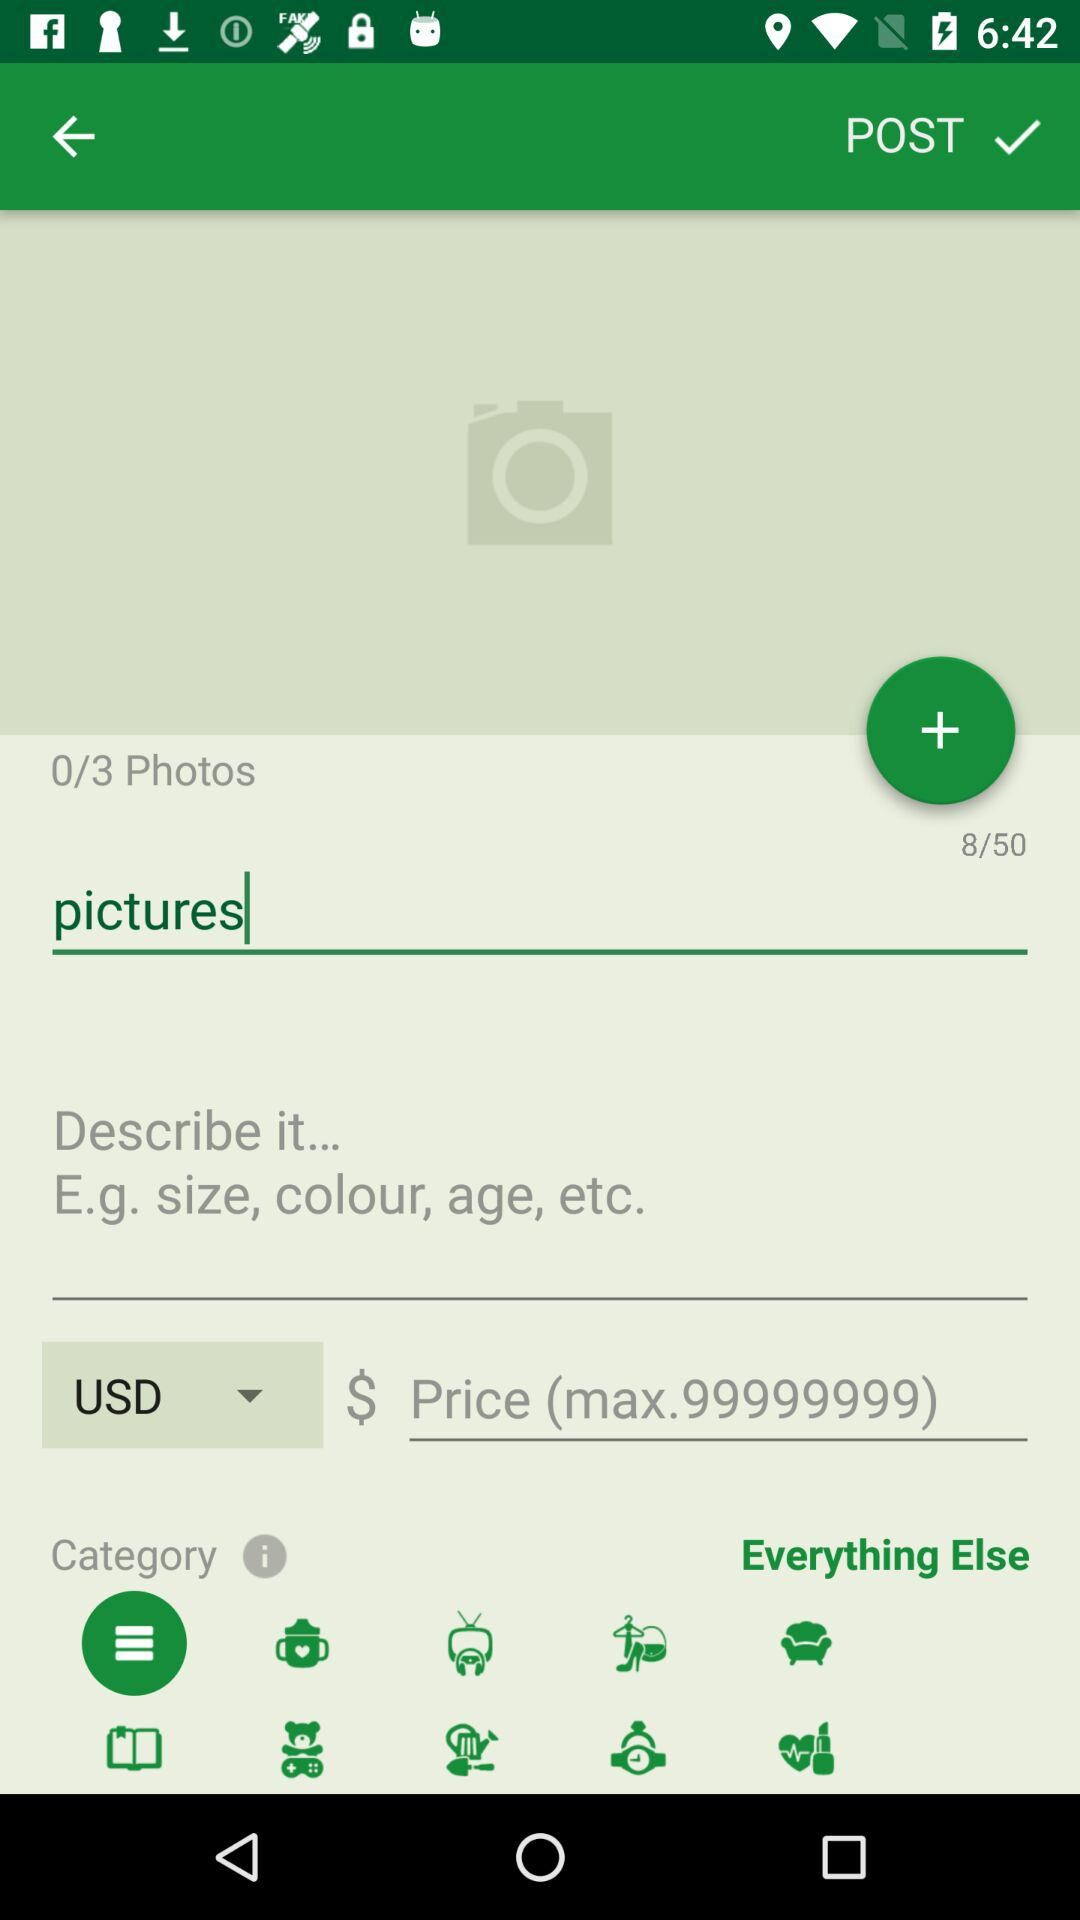What is the total number of characters I have filled? The total number of filled characters is 8. 